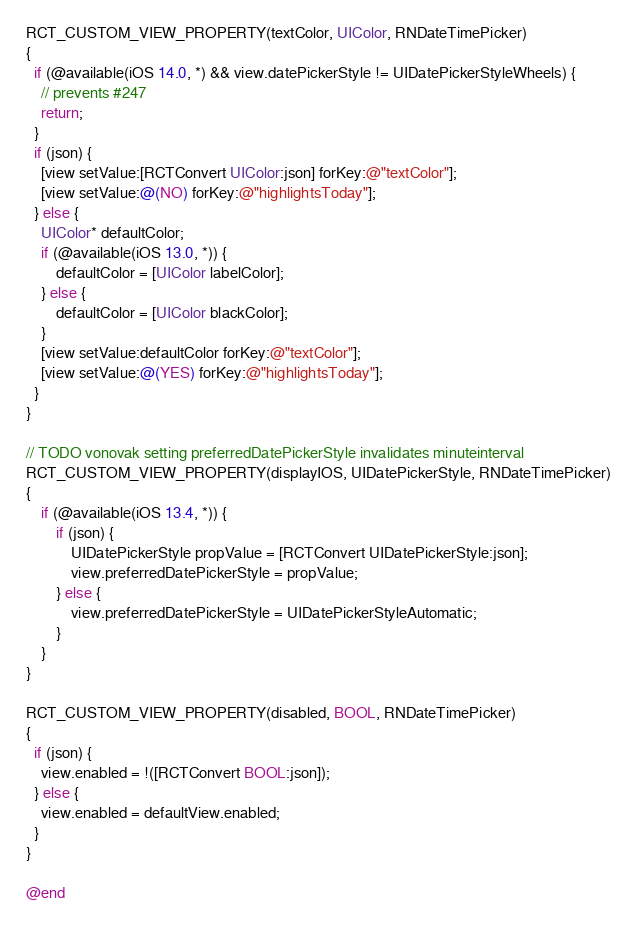<code> <loc_0><loc_0><loc_500><loc_500><_ObjectiveC_>
RCT_CUSTOM_VIEW_PROPERTY(textColor, UIColor, RNDateTimePicker)
{
  if (@available(iOS 14.0, *) && view.datePickerStyle != UIDatePickerStyleWheels) {
    // prevents #247
    return;
  }
  if (json) {
    [view setValue:[RCTConvert UIColor:json] forKey:@"textColor"];
    [view setValue:@(NO) forKey:@"highlightsToday"];
  } else {
    UIColor* defaultColor;
    if (@available(iOS 13.0, *)) {
        defaultColor = [UIColor labelColor];
    } else {
        defaultColor = [UIColor blackColor];
    }
    [view setValue:defaultColor forKey:@"textColor"];
    [view setValue:@(YES) forKey:@"highlightsToday"];
  }
}

// TODO vonovak setting preferredDatePickerStyle invalidates minuteinterval
RCT_CUSTOM_VIEW_PROPERTY(displayIOS, UIDatePickerStyle, RNDateTimePicker)
{
    if (@available(iOS 13.4, *)) {
        if (json) {
            UIDatePickerStyle propValue = [RCTConvert UIDatePickerStyle:json];
            view.preferredDatePickerStyle = propValue;
        } else {
            view.preferredDatePickerStyle = UIDatePickerStyleAutomatic;
        }
    }
}

RCT_CUSTOM_VIEW_PROPERTY(disabled, BOOL, RNDateTimePicker)
{
  if (json) {
    view.enabled = !([RCTConvert BOOL:json]);
  } else {
    view.enabled = defaultView.enabled;
  }
}

@end
</code> 